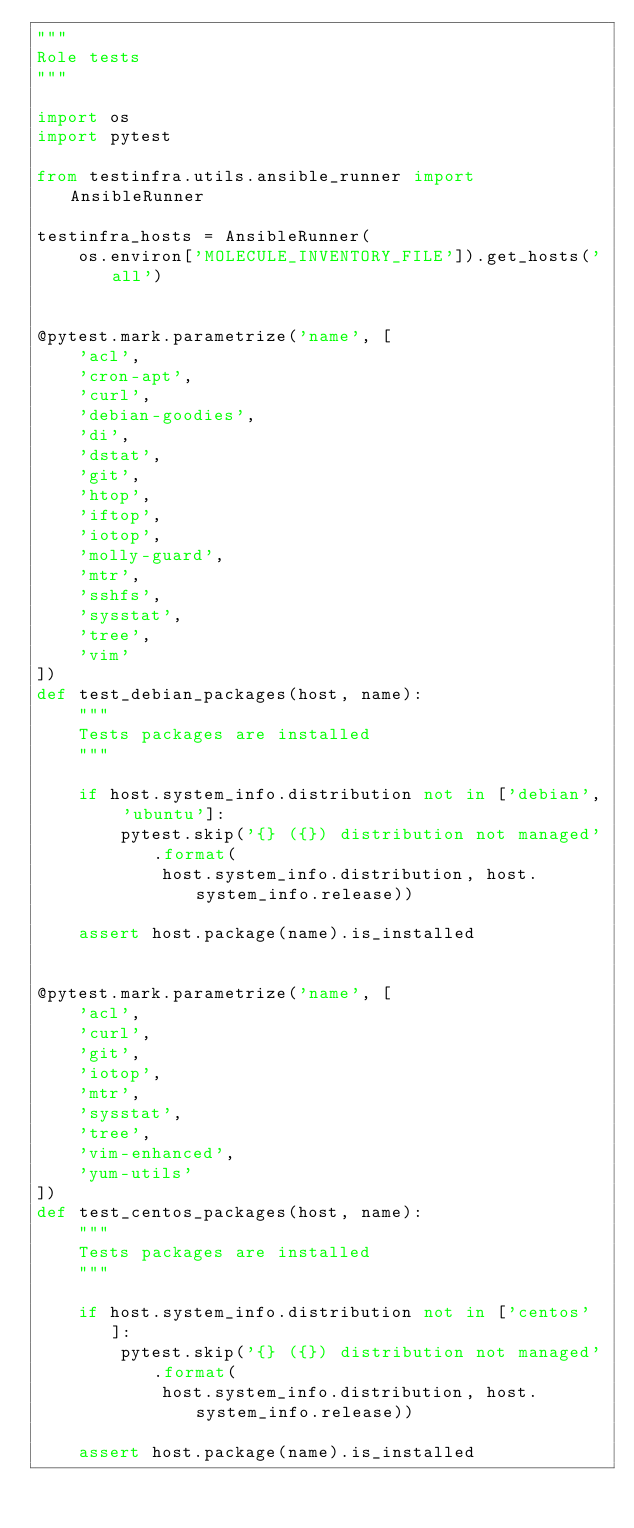<code> <loc_0><loc_0><loc_500><loc_500><_Python_>"""
Role tests
"""

import os
import pytest

from testinfra.utils.ansible_runner import AnsibleRunner

testinfra_hosts = AnsibleRunner(
    os.environ['MOLECULE_INVENTORY_FILE']).get_hosts('all')


@pytest.mark.parametrize('name', [
    'acl',
    'cron-apt',
    'curl',
    'debian-goodies',
    'di',
    'dstat',
    'git',
    'htop',
    'iftop',
    'iotop',
    'molly-guard',
    'mtr',
    'sshfs',
    'sysstat',
    'tree',
    'vim'
])
def test_debian_packages(host, name):
    """
    Tests packages are installed
    """

    if host.system_info.distribution not in ['debian', 'ubuntu']:
        pytest.skip('{} ({}) distribution not managed'.format(
            host.system_info.distribution, host.system_info.release))

    assert host.package(name).is_installed


@pytest.mark.parametrize('name', [
    'acl',
    'curl',
    'git',
    'iotop',
    'mtr',
    'sysstat',
    'tree',
    'vim-enhanced',
    'yum-utils'
])
def test_centos_packages(host, name):
    """
    Tests packages are installed
    """

    if host.system_info.distribution not in ['centos']:
        pytest.skip('{} ({}) distribution not managed'.format(
            host.system_info.distribution, host.system_info.release))

    assert host.package(name).is_installed
</code> 